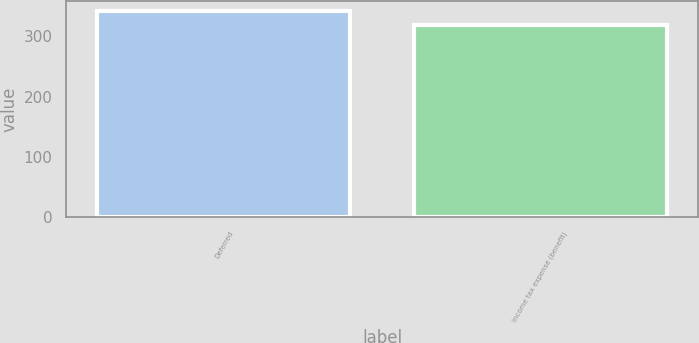<chart> <loc_0><loc_0><loc_500><loc_500><bar_chart><fcel>Deferred<fcel>Income tax expense (benefit)<nl><fcel>342<fcel>319<nl></chart> 